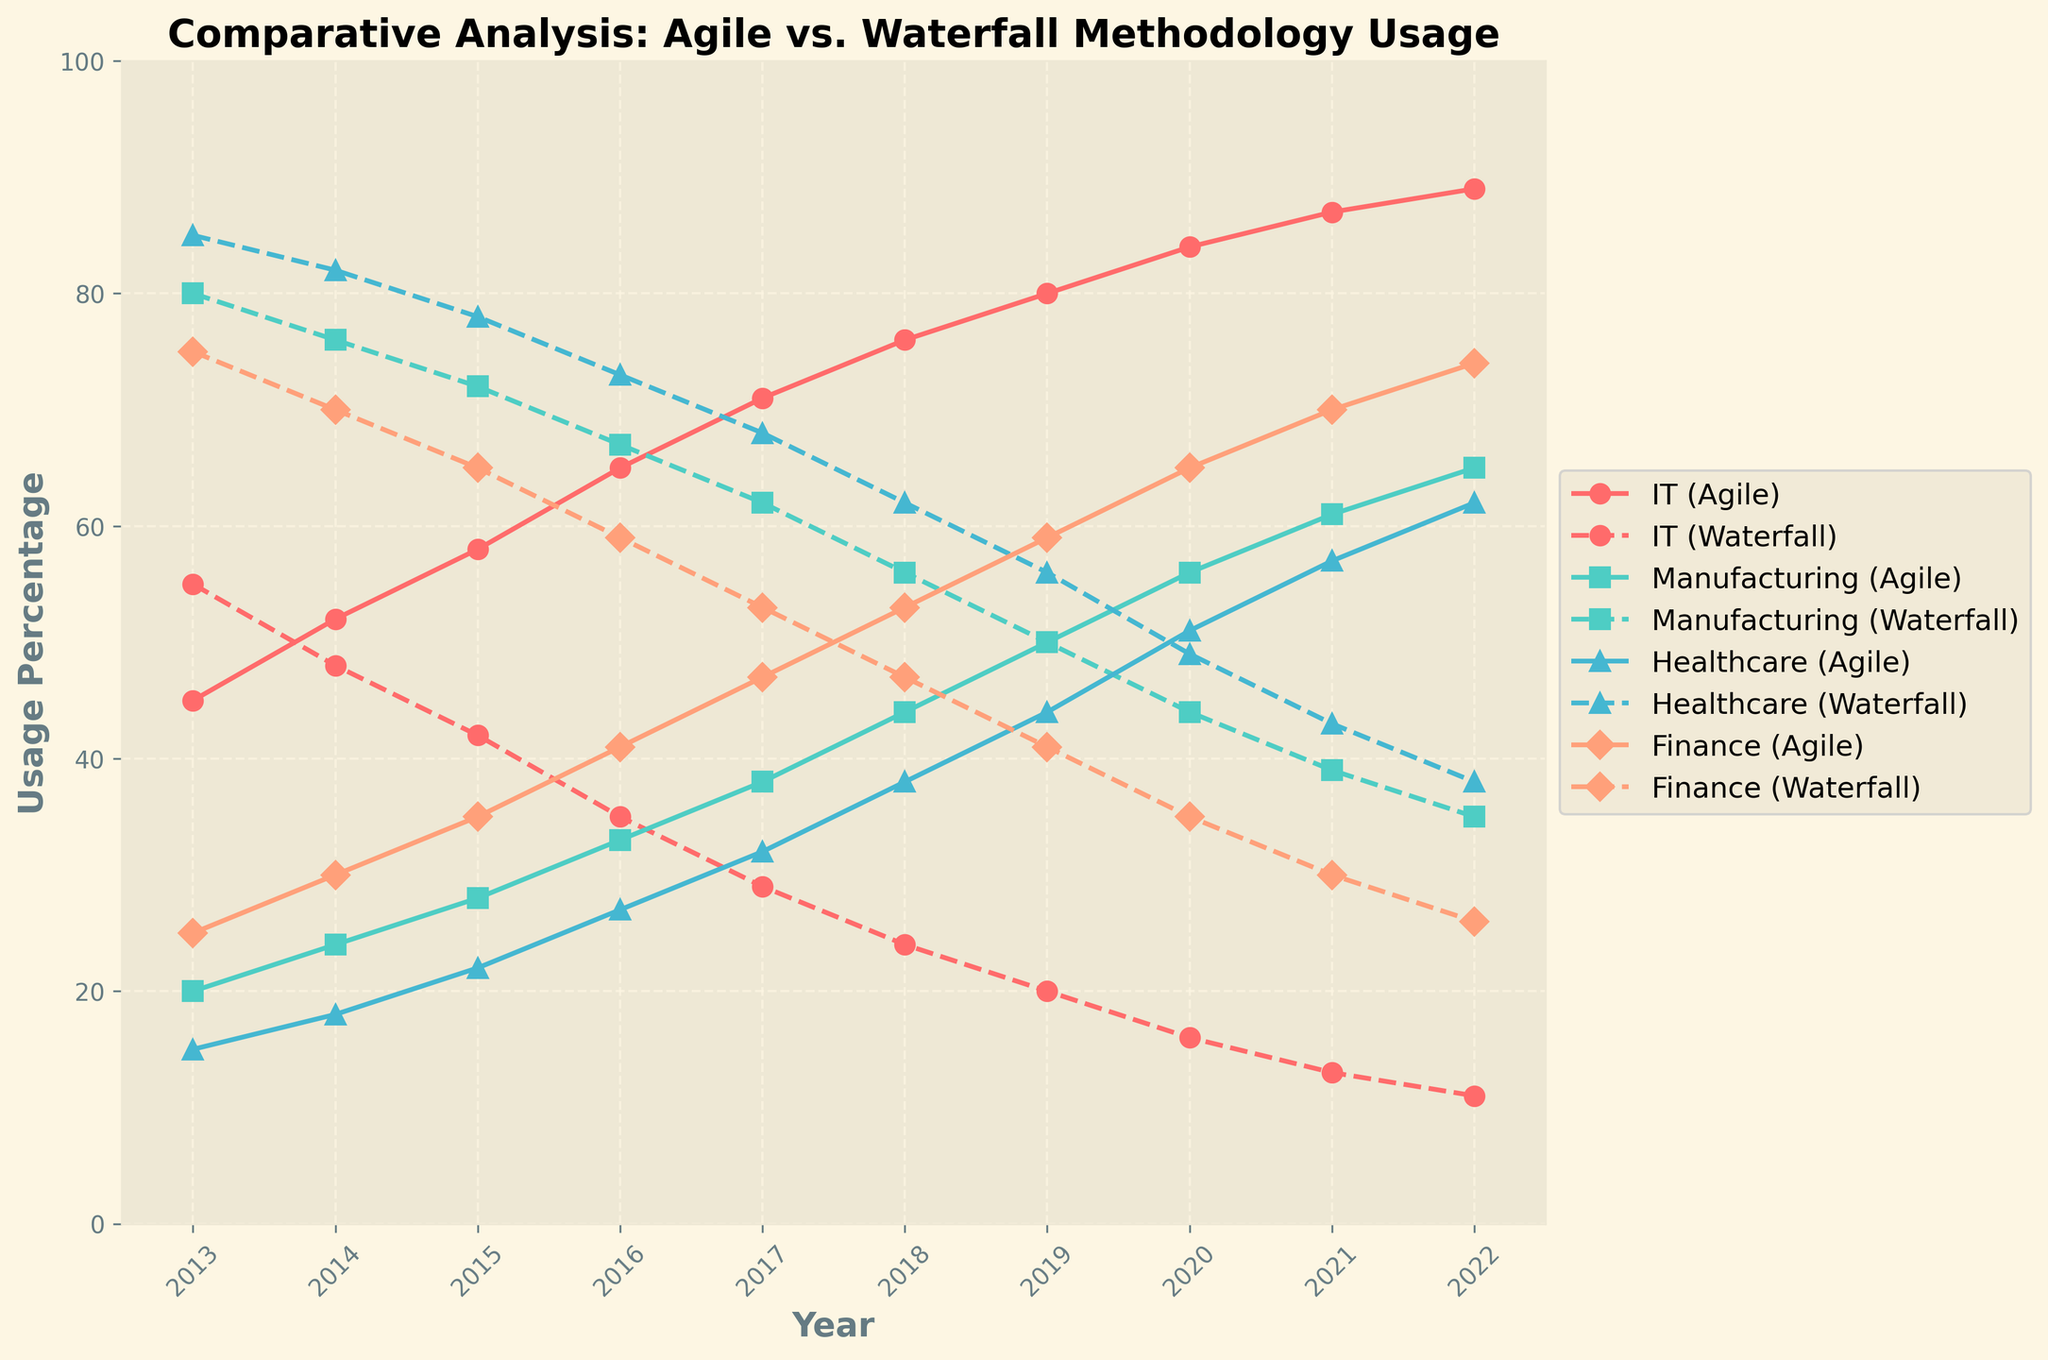What is the trend for Agile methodology usage in the IT sector over the past decade? The Agile methodology usage in the IT sector shows an increasing trend over the past decade, rising from 45% in 2013 to 89% in 2022.
Answer: Increasing Which sector had the highest increase in Agile methodology usage from 2013 to 2022? To determine this, we look at the increase in Agile usage for each sector: 
- IT: 89% - 45% = 44%
- Manufacturing: 65% - 20% = 45%
- Healthcare: 62% - 15% = 47%
- Finance: 74% - 25% = 49%
The Finance sector saw the highest increase in Agile usage (49%).
Answer: Finance In 2020, which sector had the closest percentage of Agile and Waterfall methodology usage? In 2020, we compare the gap between Agile and Waterfall usage for each sector:
- IT: 84% Agile vs. 16% Waterfall (gap 68%)
- Manufacturing: 56% Agile vs. 44% Waterfall (gap 12%)
- Healthcare: 51% Agile vs. 49% Waterfall (gap 2%)
- Finance: 65% Agile vs. 35% Waterfall (gap 30%)
Healthcare had the closest percentage of Agile and Waterfall usage with only a 2% gap.
Answer: Healthcare How did the Agile methodology usage in the Healthcare sector compare to the Waterfall methodology usage in the same sector in 2019? In 2019, Agile methodology usage in the Healthcare sector was 44%, while Waterfall methodology usage was 56%. Agile usage was less than Waterfall usage by 12%.
Answer: Agile was 12% lower By how much did the Agile methodology usage in the Manufacturing sector increase from 2016 to 2018? In 2016, Agile usage in Manufacturing was 33%, and in 2018, it was 44%. The increase from 2016 to 2018 is 44% - 33% = 11%.
Answer: 11% What was the average usage of Agile methodology in the Finance sector from 2013 to 2022? To find the average Agile usage in the Finance sector over these years:
Sum: 25+30+35+41+47+53+59+65+70+74 = 499
Number of years: 10
Average = 499 / 10 = 49.9%
Answer: 49.9% In which year did the Agile methodology usage in the IT sector surpass 70%? By observing the trend in IT, Agile usage surpasses 70% in the year 2017, where it is recorded at 71%.
Answer: 2017 Between the years 2017 and 2018, in which sector did Agile methodology usage see the largest year-to-year increase? To compare:
- IT: 76% in 2018 - 71% in 2017 = 5%
- Manufacturing: 44% in 2018 - 38% in 2017 = 6%
- Healthcare: 38% in 2018 - 32% in 2017 = 6%
- Finance: 53% in 2018 - 47% in 2017 = 6%
Three sectors (Manufacturing, Healthcare and Finance) saw the largest increase of 6%.
Answer: Manufacturing, Healthcare, Finance 